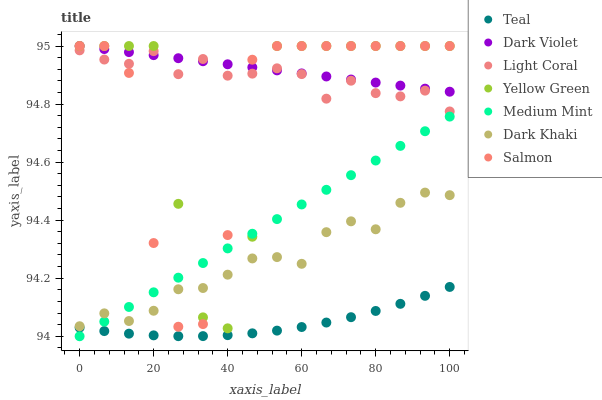Does Teal have the minimum area under the curve?
Answer yes or no. Yes. Does Dark Violet have the maximum area under the curve?
Answer yes or no. Yes. Does Dark Khaki have the minimum area under the curve?
Answer yes or no. No. Does Dark Khaki have the maximum area under the curve?
Answer yes or no. No. Is Dark Violet the smoothest?
Answer yes or no. Yes. Is Yellow Green the roughest?
Answer yes or no. Yes. Is Dark Khaki the smoothest?
Answer yes or no. No. Is Dark Khaki the roughest?
Answer yes or no. No. Does Medium Mint have the lowest value?
Answer yes or no. Yes. Does Dark Khaki have the lowest value?
Answer yes or no. No. Does Dark Violet have the highest value?
Answer yes or no. Yes. Does Dark Khaki have the highest value?
Answer yes or no. No. Is Teal less than Yellow Green?
Answer yes or no. Yes. Is Dark Khaki greater than Teal?
Answer yes or no. Yes. Does Dark Violet intersect Salmon?
Answer yes or no. Yes. Is Dark Violet less than Salmon?
Answer yes or no. No. Is Dark Violet greater than Salmon?
Answer yes or no. No. Does Teal intersect Yellow Green?
Answer yes or no. No. 